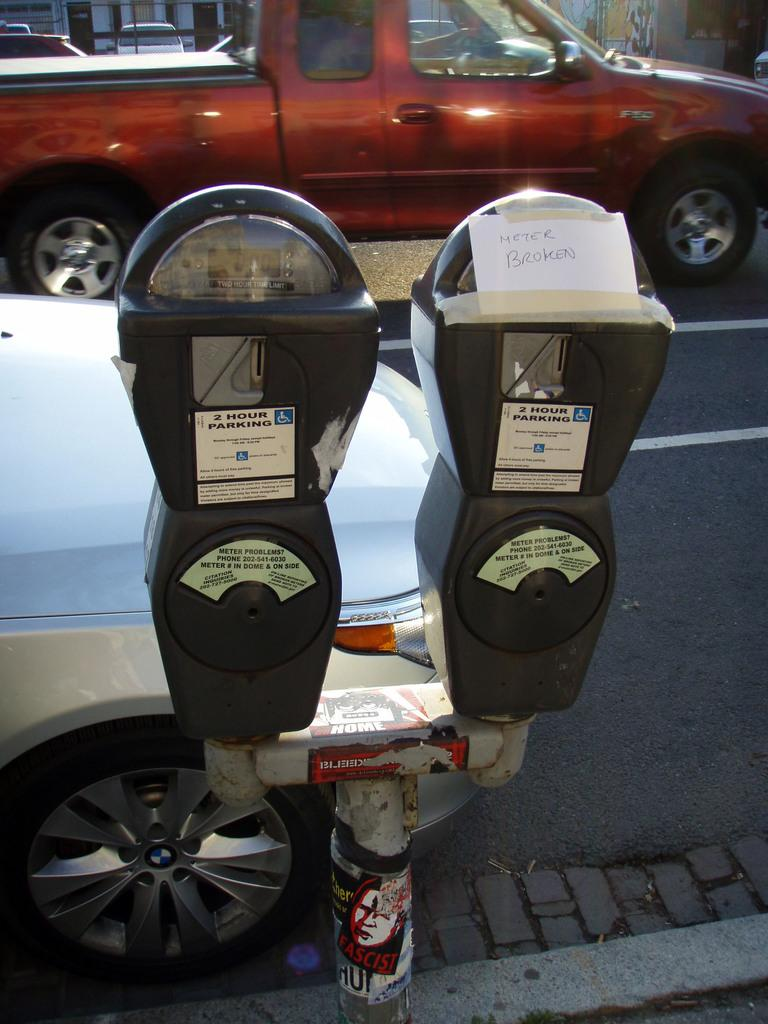Provide a one-sentence caption for the provided image. A parking meter has a note taped to it that says "Meter Broken". 